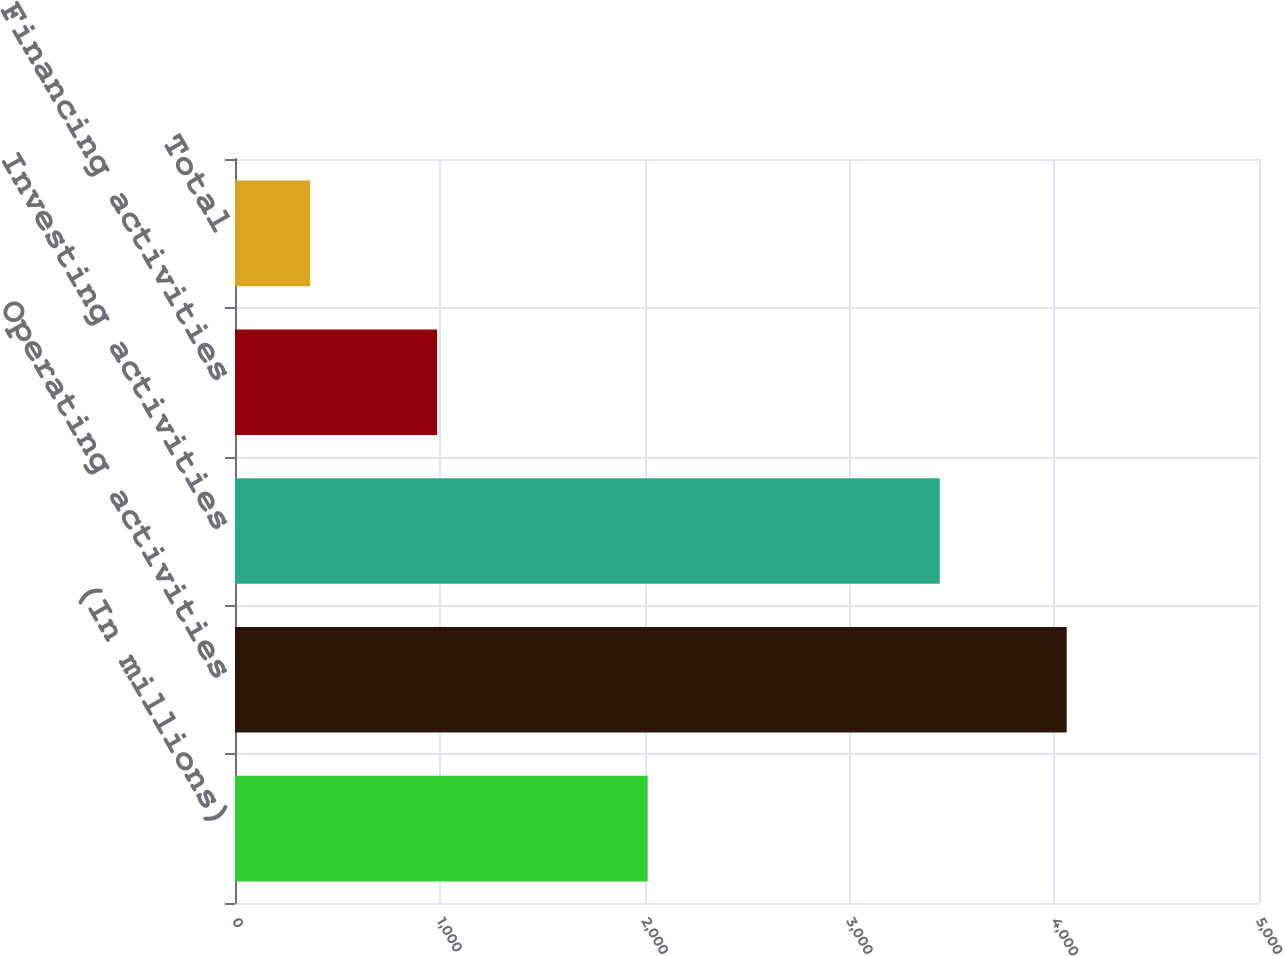<chart> <loc_0><loc_0><loc_500><loc_500><bar_chart><fcel>(In millions)<fcel>Operating activities<fcel>Investing activities<fcel>Financing activities<fcel>Total<nl><fcel>2015<fcel>4061<fcel>3441<fcel>987<fcel>367<nl></chart> 